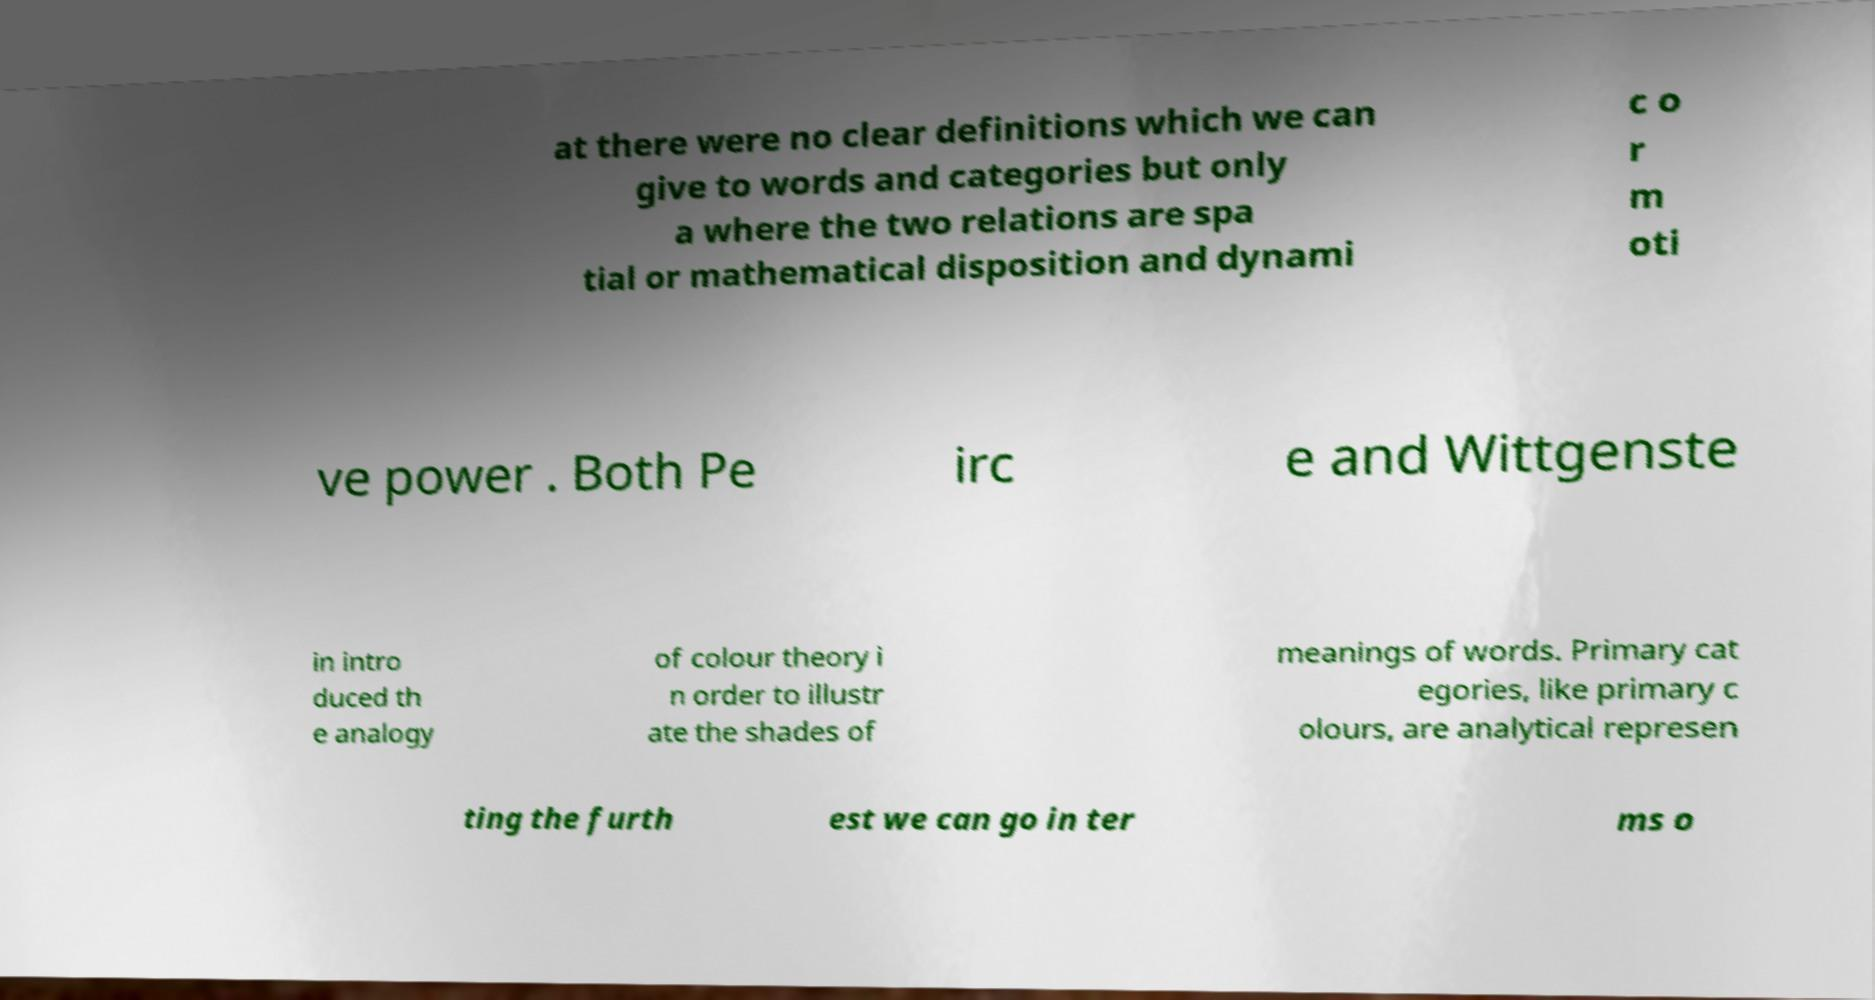Could you assist in decoding the text presented in this image and type it out clearly? at there were no clear definitions which we can give to words and categories but only a where the two relations are spa tial or mathematical disposition and dynami c o r m oti ve power . Both Pe irc e and Wittgenste in intro duced th e analogy of colour theory i n order to illustr ate the shades of meanings of words. Primary cat egories, like primary c olours, are analytical represen ting the furth est we can go in ter ms o 